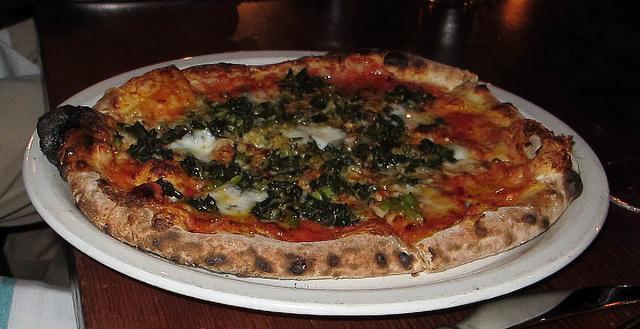How many knives are there?
Give a very brief answer. 1. How many people are playing with sheep?
Give a very brief answer. 0. 